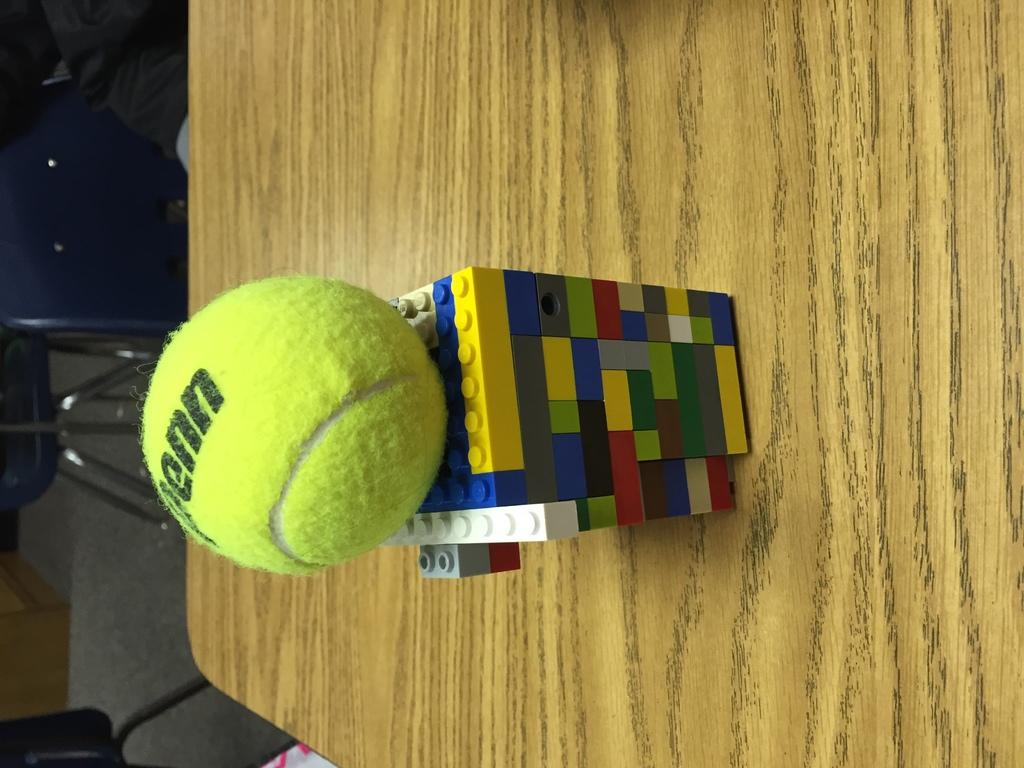What type of toy is featured in the image? There are Lego pieces in the image. What can be said about the colors of the Lego pieces? The Lego pieces are in multiple colors. On what surface are the Lego pieces placed? The Lego pieces are on a wooden surface. What other object can be seen in the image besides the Lego pieces? There is: There is a green ball in the image. How does the nerve system of the Lego pieces function in the image? Lego pieces do not have a nerve system, as they are inanimate objects. 